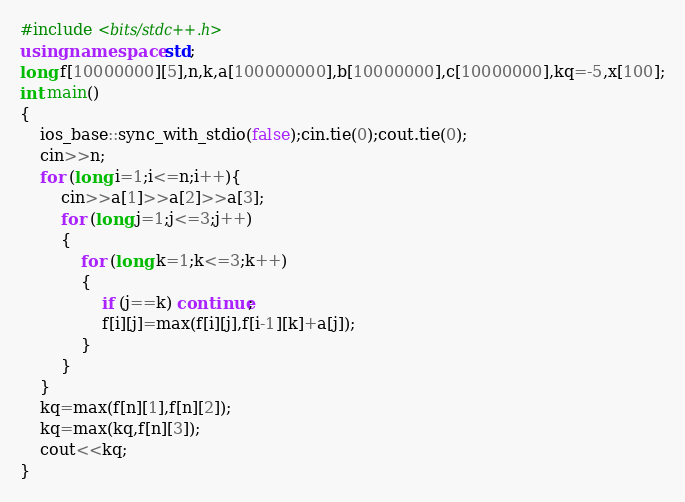<code> <loc_0><loc_0><loc_500><loc_500><_C++_>#include <bits/stdc++.h>
using namespace std;
long f[10000000][5],n,k,a[100000000],b[10000000],c[10000000],kq=-5,x[100];
int main()
{
    ios_base::sync_with_stdio(false);cin.tie(0);cout.tie(0);
    cin>>n;
    for (long i=1;i<=n;i++){
        cin>>a[1]>>a[2]>>a[3];
        for (long j=1;j<=3;j++)
        {
            for (long k=1;k<=3;k++)
            {
                if (j==k) continue;
                f[i][j]=max(f[i][j],f[i-1][k]+a[j]);
            }
        }
    }
    kq=max(f[n][1],f[n][2]);
    kq=max(kq,f[n][3]);
    cout<<kq;
}
</code> 